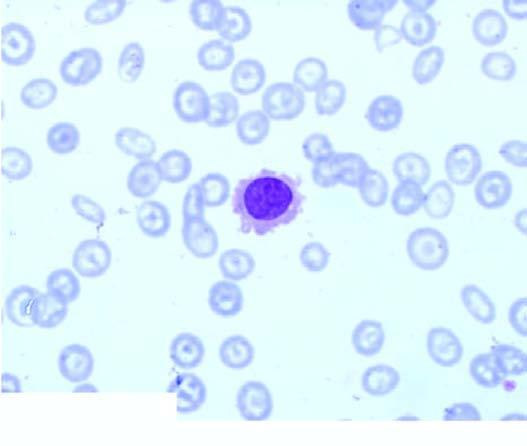does the rephine biopsy show replacement of marrow spaces with abnormal mononuclear cells?
Answer the question using a single word or phrase. Yes 